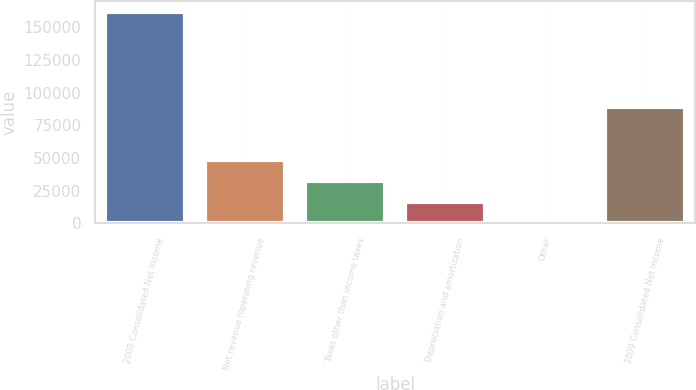<chart> <loc_0><loc_0><loc_500><loc_500><bar_chart><fcel>2008 Consolidated Net Income<fcel>Net revenue (operating revenue<fcel>Taxes other than income taxes<fcel>Depreciation and amortization<fcel>Other<fcel>2009 Consolidated Net Income<nl><fcel>161889<fcel>48570.2<fcel>32381.8<fcel>16193.4<fcel>5<fcel>88875<nl></chart> 